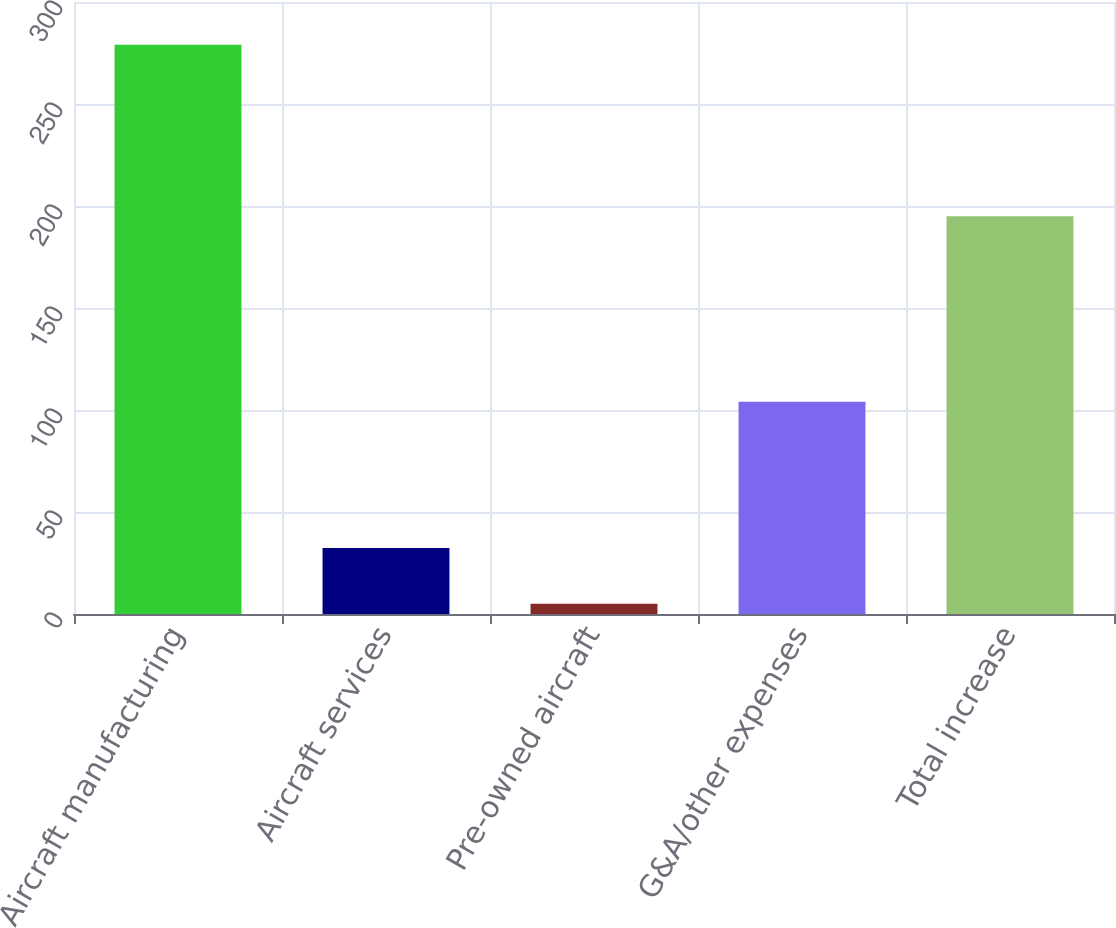<chart> <loc_0><loc_0><loc_500><loc_500><bar_chart><fcel>Aircraft manufacturing<fcel>Aircraft services<fcel>Pre-owned aircraft<fcel>G&A/other expenses<fcel>Total increase<nl><fcel>279<fcel>32.4<fcel>5<fcel>104<fcel>195<nl></chart> 